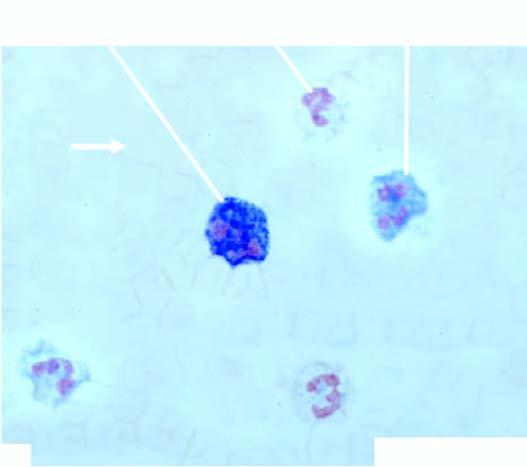what do peripheral blood film show?
Answer the question using a single word or phrase. Marked neutrophilic leucocytosis accompanied with late precursors of myeloid series 